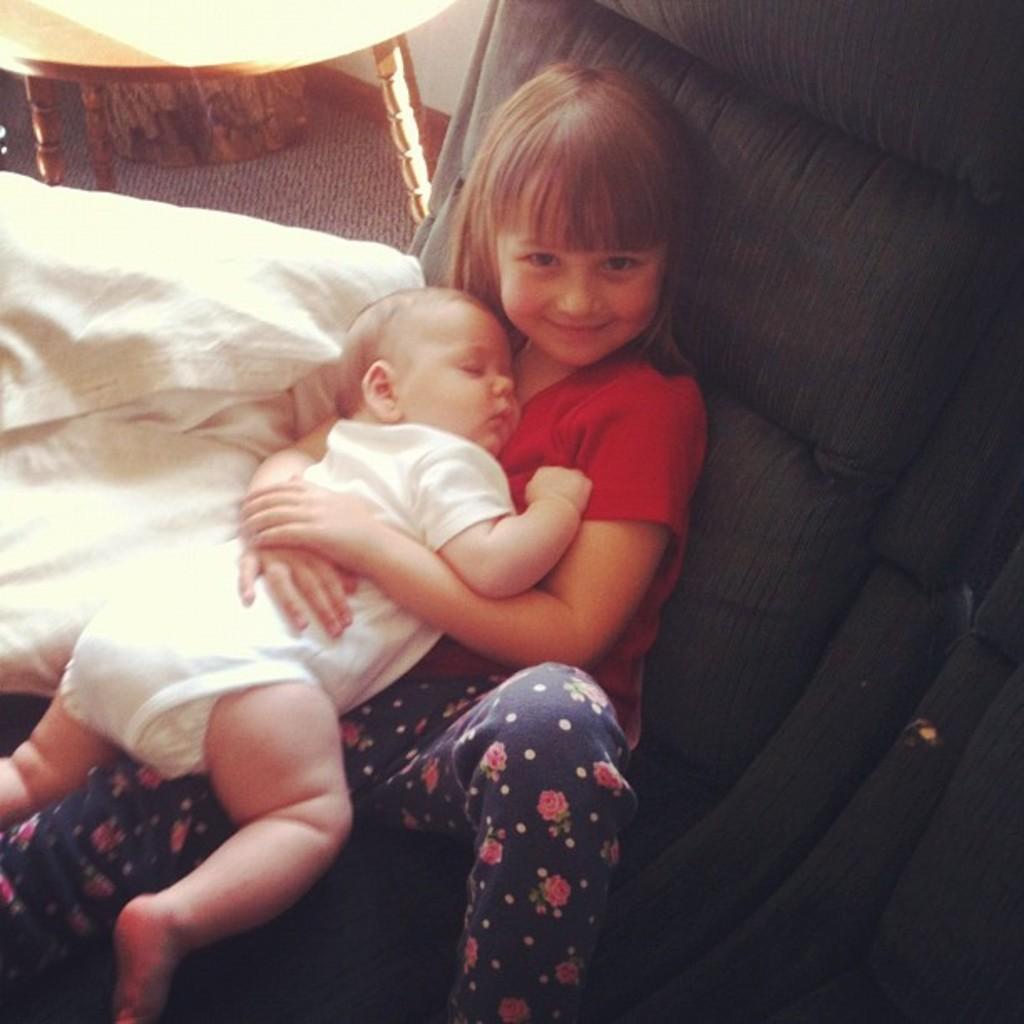Could you give a brief overview of what you see in this image? This picture is taken inside the room. In this image, in the middle, we can see a girl sitting on the couch, we can also see a girl is holding a kid in her hand. On the left side, we can also see a white color and a table, under the table, we can see an object and a mat. 